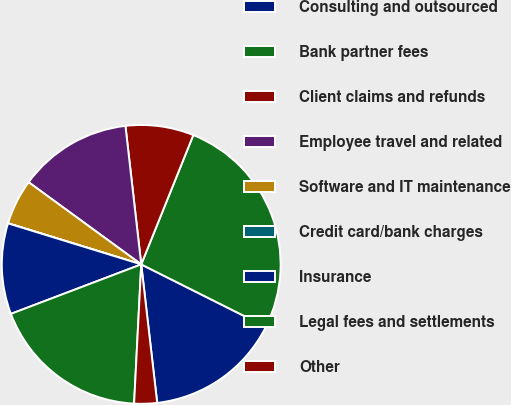<chart> <loc_0><loc_0><loc_500><loc_500><pie_chart><fcel>Consulting and outsourced<fcel>Bank partner fees<fcel>Client claims and refunds<fcel>Employee travel and related<fcel>Software and IT maintenance<fcel>Credit card/bank charges<fcel>Insurance<fcel>Legal fees and settlements<fcel>Other<nl><fcel>15.78%<fcel>26.3%<fcel>7.9%<fcel>13.16%<fcel>5.27%<fcel>0.01%<fcel>10.53%<fcel>18.41%<fcel>2.64%<nl></chart> 